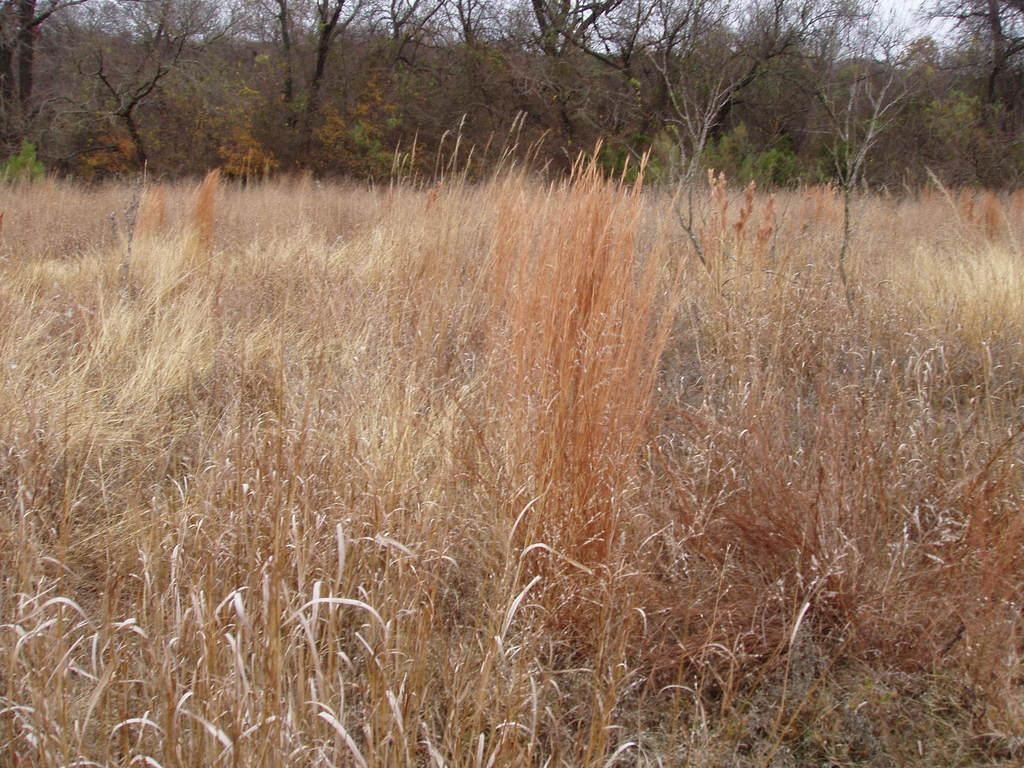What type of vegetation can be seen in the image? There is dry grass, plants, and trees in the image. What part of the natural environment is visible in the image? The sky is visible in the image. What is the opinion of the page in the image? There is no page present in the image, so it is not possible to determine its opinion. 